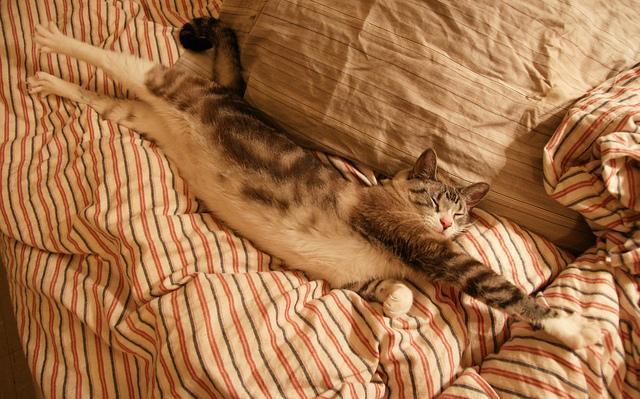How many chairs are around the circle table?
Give a very brief answer. 0. 